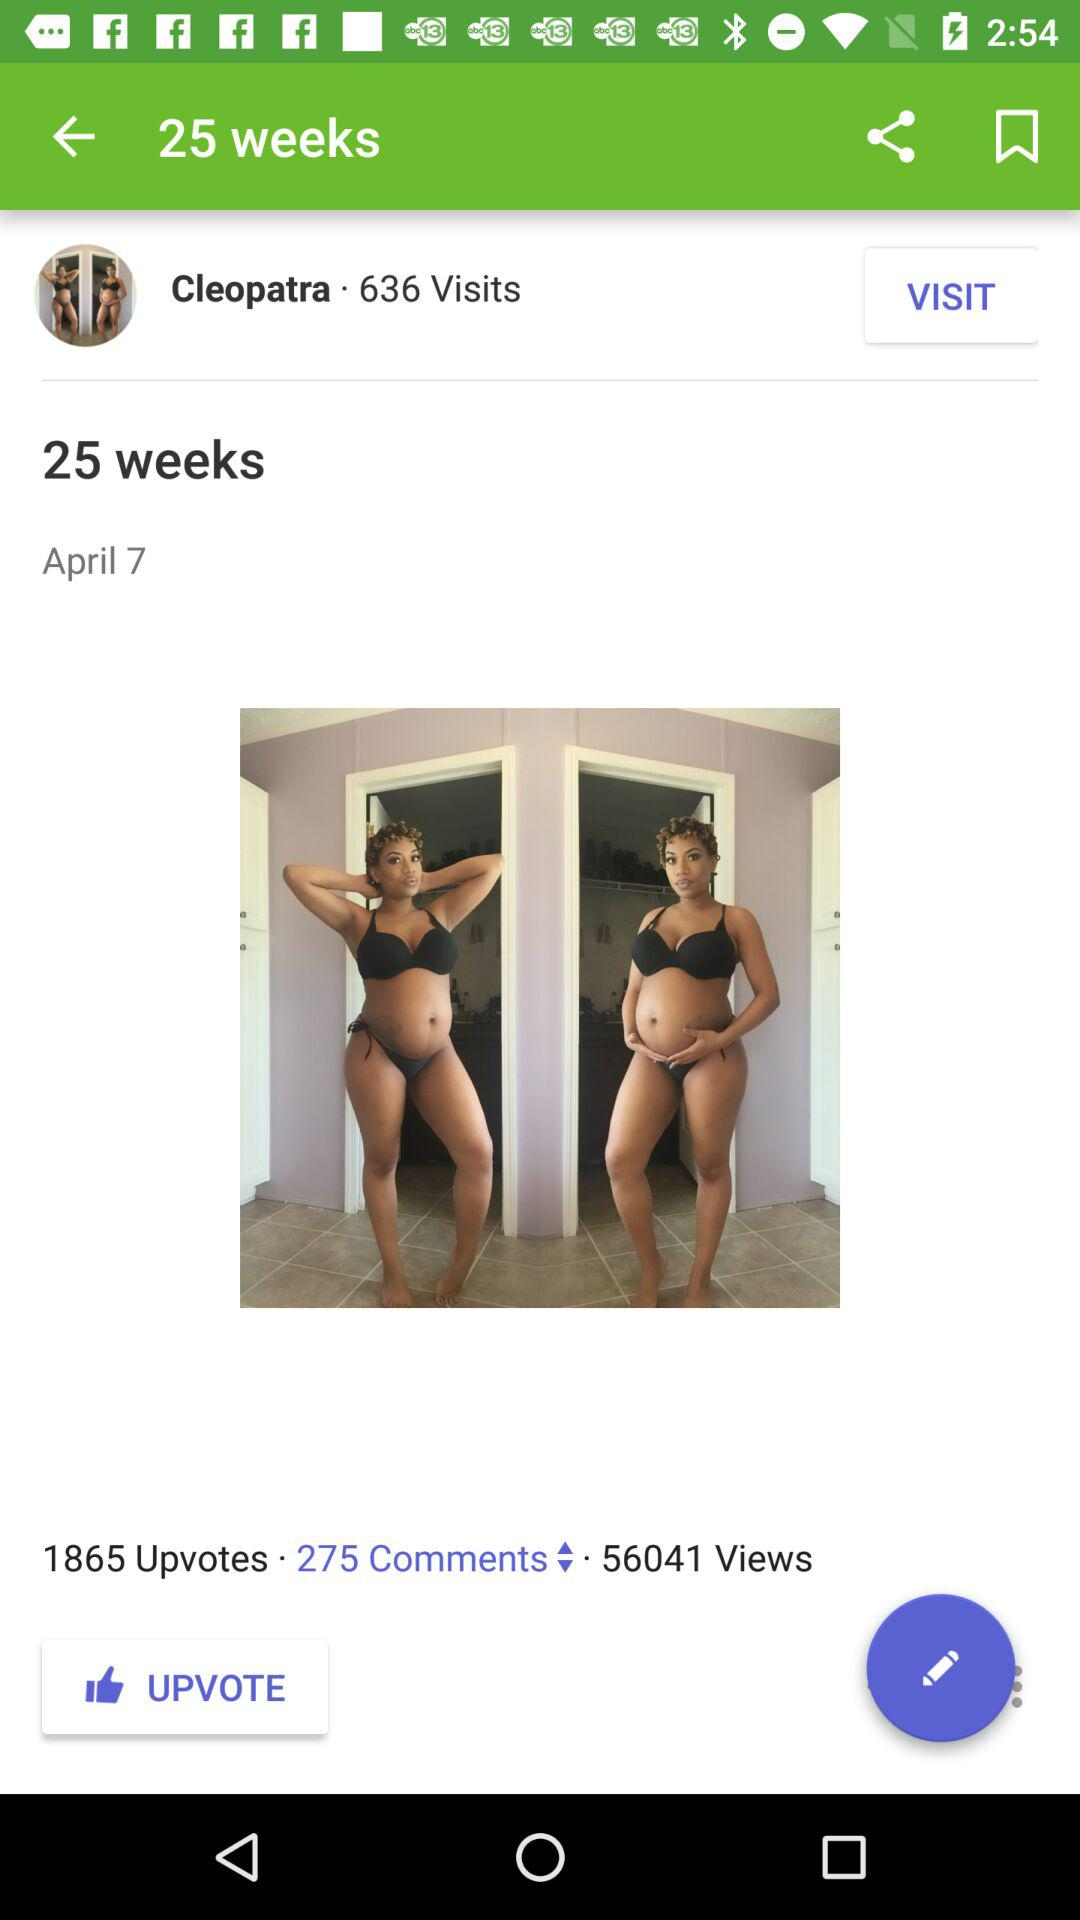What is the mentioned date? The mentioned date is April 7. 